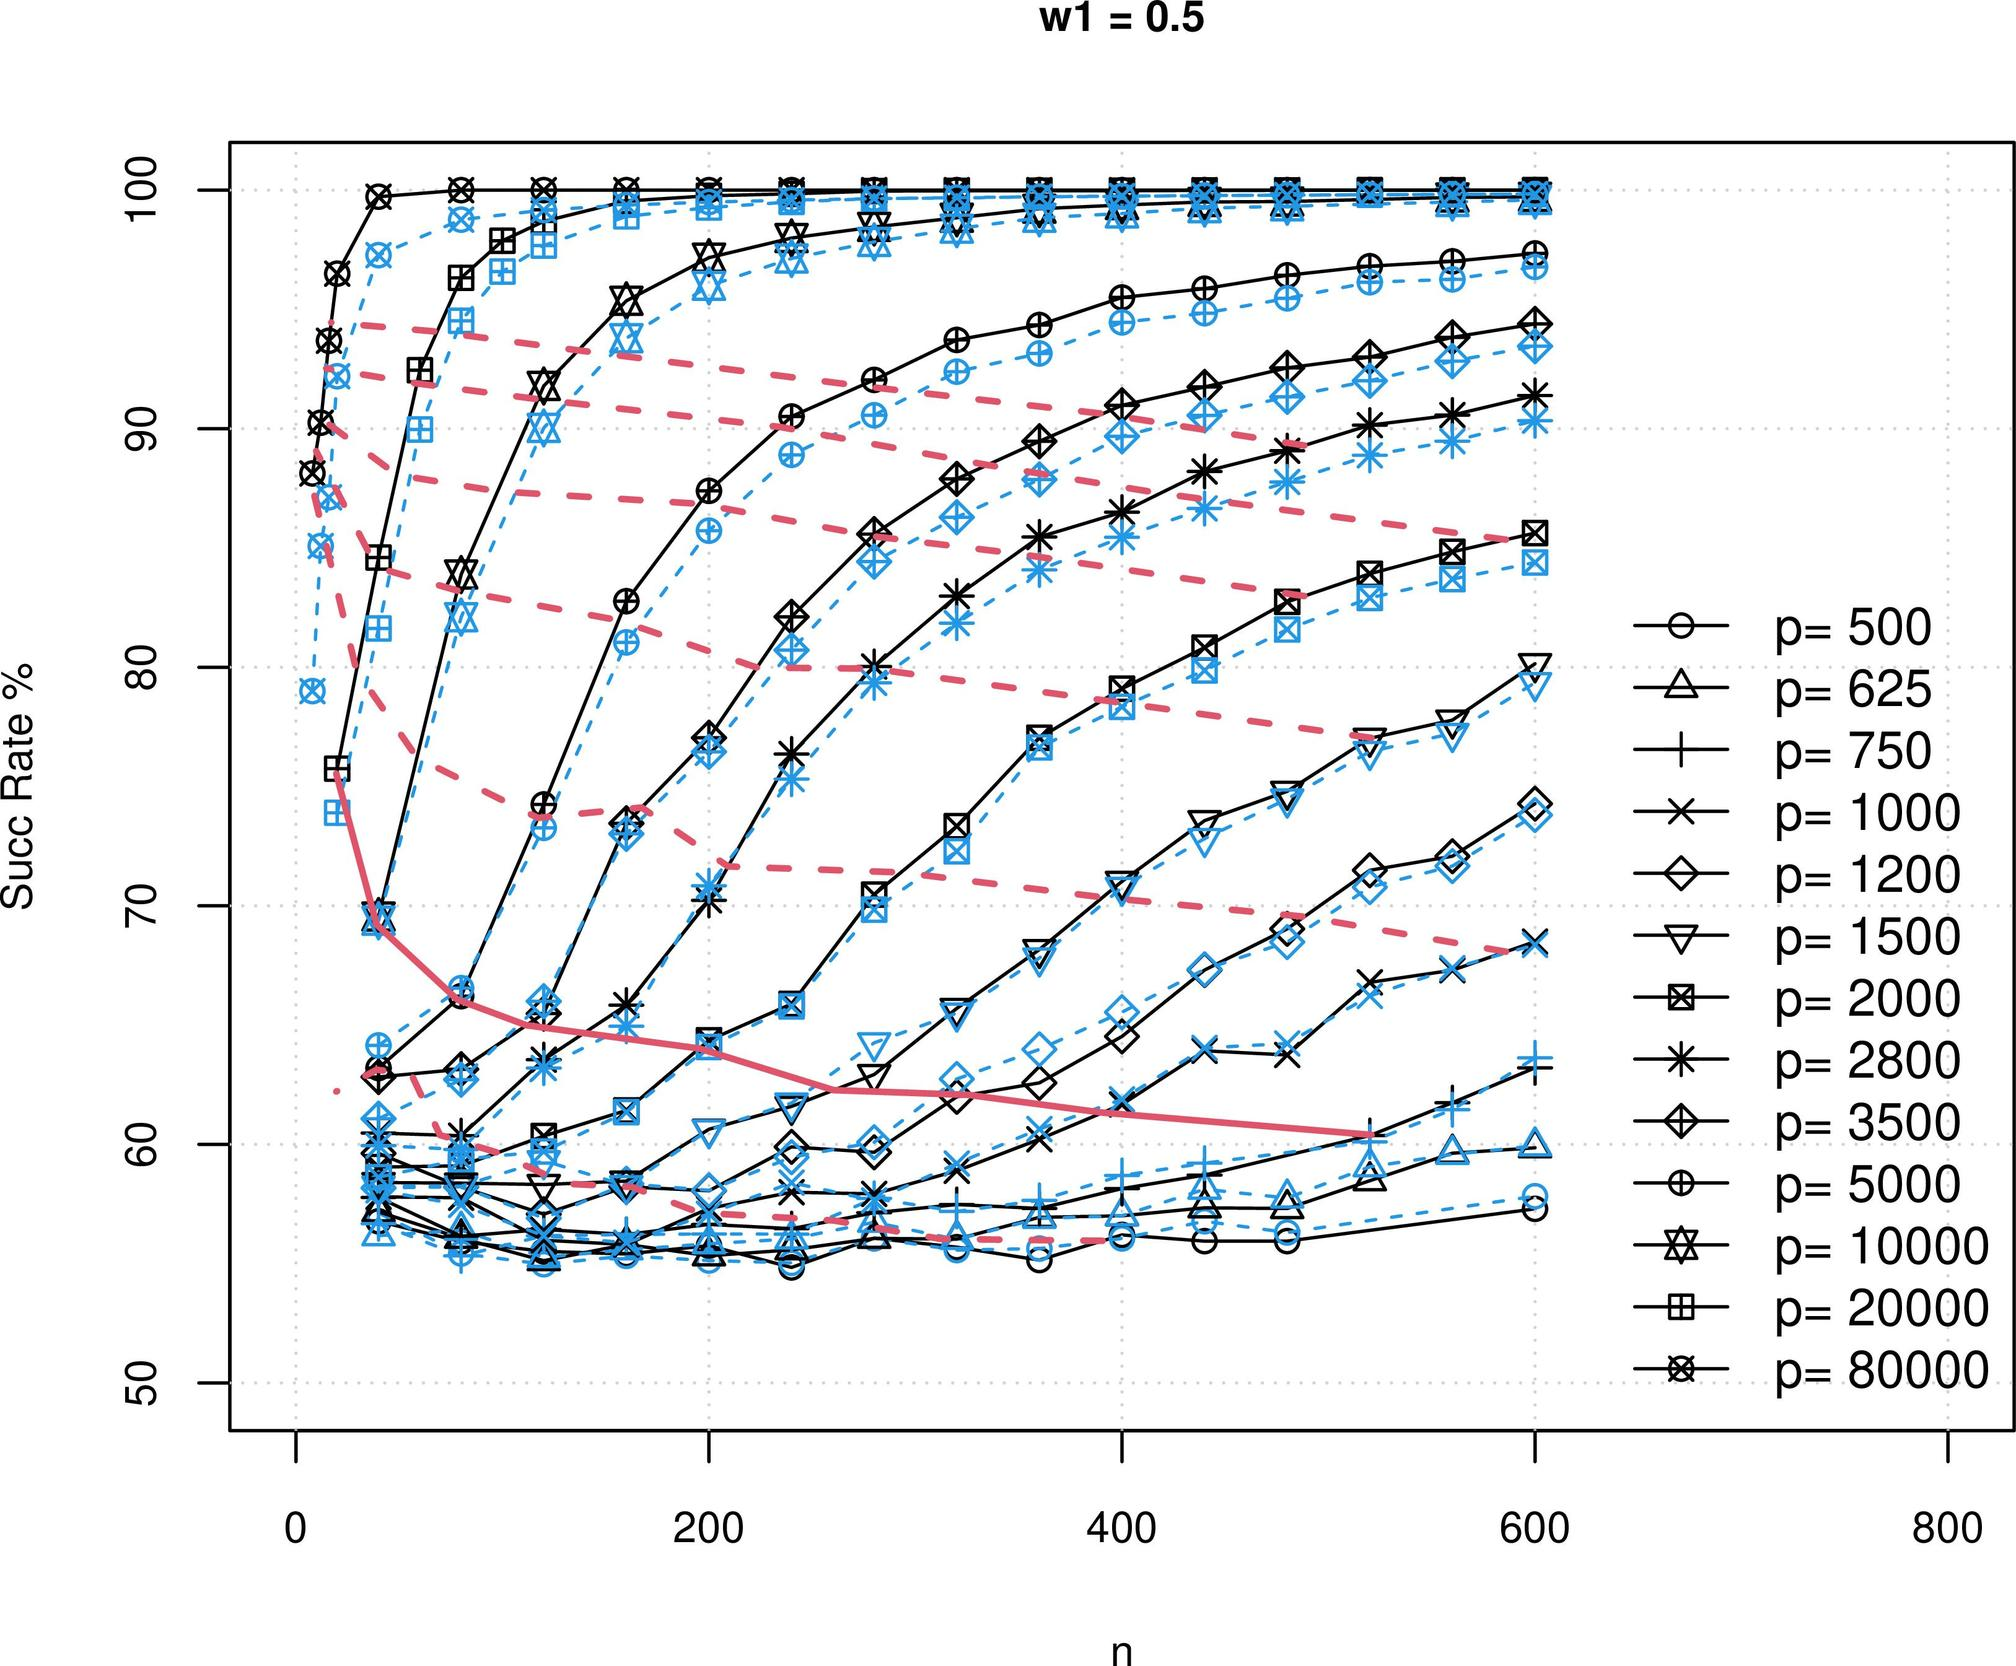Based on the graph, what can be inferred about the relationship between 'n' and the success rate for a fixed 'p' value? A. 'n' and the success rate are inversely proportional. B. 'n' and the success rate are directly proportional. C. 'n' has a sporadic effect on the success rate. D. 'n' does not affect the success rate. Each line in the graph represents a constant 'p' value, and as 'n' increases from left to right, the success rate also increases, showing a direct proportionality between 'n' and the success rate for a given 'p'. Therefore, the correct answer is B. 